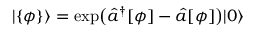Convert formula to latex. <formula><loc_0><loc_0><loc_500><loc_500>| \{ \phi \} \rangle = \exp \left ( \hat { a } ^ { \dagger } [ \phi ] - \hat { a } [ \phi ] \right ) | 0 \rangle</formula> 